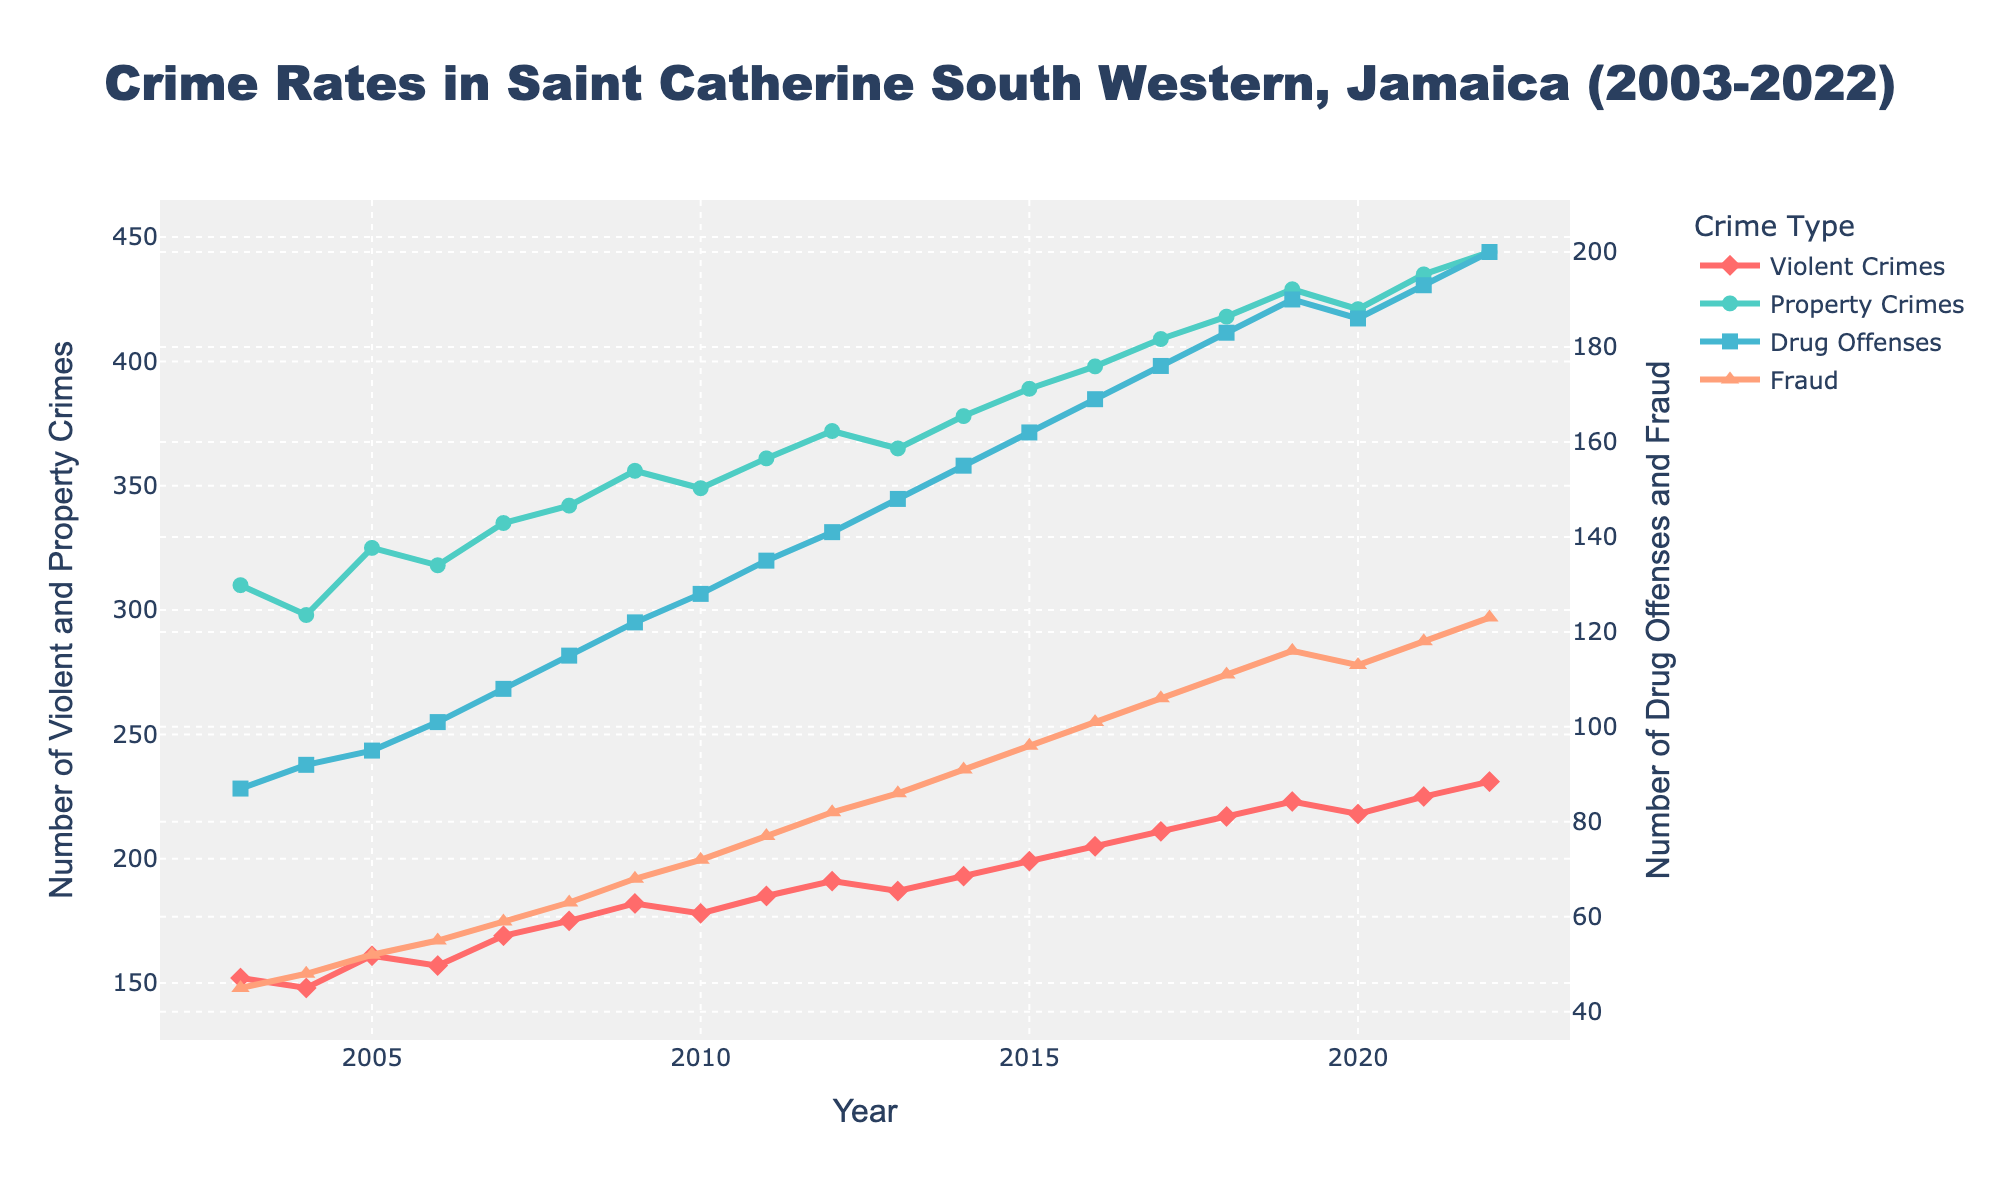What type of crime has seen the highest increase over the past 20 years? To answer this, we need to determine the starting and ending values for each crime type and calculate the increase: 
- Violent Crimes: 231 (2022) - 152 (2003) = 79
- Property Crimes: 444 (2022) - 310 (2003) = 134
- Drug Offenses: 200 (2022) - 87 (2003) = 113
- Fraud: 123 (2022) - 45 (2003) = 78
Comparing these increases, Property Crimes have increased the most, by 134.
Answer: Property Crimes Which type of crime had the lowest number in 2022? Looking at the endpoints of each line in 2022:
- Violent Crimes: 231
- Property Crimes: 444
- Drug Offenses: 200
- Fraud: 123
The lowest value is for Fraud at 123.
Answer: Fraud In which year did Drug Offenses surpass 150 cases? Observe the Drug Offenses data points over time:
- 2014: 155
Since Drug Offenses surpassed 150 cases in 2014.
Answer: 2014 What is the sum of Fraud cases in 2010 and 2020? Sum the values from the graph for these years:
- Fraud in 2010: 72
- Fraud in 2020: 113
Sum: 72 + 113 = 185
Answer: 185 Were there any years when the number of Violent Crimes decreased compared to the previous year? If so, which years? Look for points where the line for Violent Crimes goes down from one year to the next:
- 2004 compared to 2003: Yes (148 < 152)
- 2006 compared to 2005: Yes (157 < 161)
- 2010 compared to 2009: Yes (178 < 182)
- 2013 compared to 2012: Yes (187 < 191)
- 2020 compared to 2019: Yes (218 < 223)
So, the Violent Crimes decreased in these years.
Answer: 2004, 2006, 2010, 2013, 2020 Which crime type consistently showed an upward trend every year without any decline? Analyze each line on the graph:
- Violent Crimes: Declines observed.
- Property Crimes: No declines observed.
- Drug Offenses: No declines observed.
- Fraud: No declines observed.
Property Crimes, Drug Offenses, and Fraud each show a consistent upward trend with no declines.
Answer: Property Crimes, Drug Offenses, Fraud How does the trend of Property Crimes between 2003 and 2022 visually compare to that of Violent Crimes over the same period? By examining the slopes and trends:
- Property Crimes show a steady and consistent increase.
- Violent Crimes also increase, but with periods of both increase and decrease, resulting in a more fluctuating trend line.
Thus, Property Crimes present a more linear rise compared to Violent Crimes that display both increases and dips.
Answer: Property Crimes are more consistent, Violent Crimes fluctuate more What is the average number of Drug Offenses in the first 5 years (2003-2007)? Calculate the average using the first 5 years' Drug Offenses values:
- 2003: 87, 2004: 92, 2005: 95, 2006: 101, 2007: 108
Sum: 87 + 92 + 95 + 101 + 108 = 483
Average: 483 / 5 = 96.6
Answer: 96.6 How did the number of Fraud cases in 2015 compare to the number of Drug Offenses that same year? Look at the data points for 2015:
- Fraud: 96
- Drug Offenses: 162
Fraud cases were lower than Drug Offenses in 2015.
Answer: Fraud is lower 